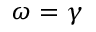Convert formula to latex. <formula><loc_0><loc_0><loc_500><loc_500>\omega = \gamma</formula> 